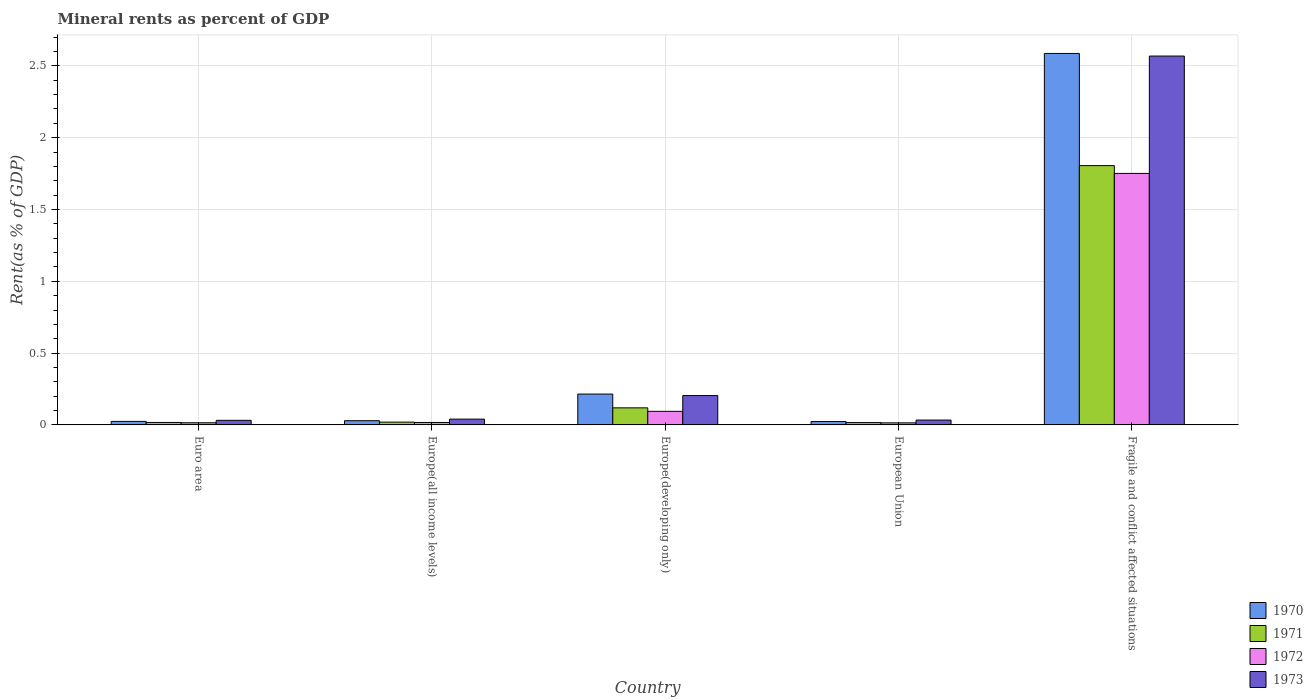How many bars are there on the 5th tick from the right?
Your response must be concise. 4. What is the label of the 4th group of bars from the left?
Provide a succinct answer. European Union. What is the mineral rent in 1971 in Europe(developing only)?
Offer a terse response. 0.12. Across all countries, what is the maximum mineral rent in 1971?
Give a very brief answer. 1.81. Across all countries, what is the minimum mineral rent in 1971?
Give a very brief answer. 0.02. In which country was the mineral rent in 1972 maximum?
Ensure brevity in your answer.  Fragile and conflict affected situations. What is the total mineral rent in 1972 in the graph?
Your answer should be very brief. 1.89. What is the difference between the mineral rent in 1971 in Europe(developing only) and that in European Union?
Your response must be concise. 0.1. What is the difference between the mineral rent in 1971 in Europe(developing only) and the mineral rent in 1973 in European Union?
Ensure brevity in your answer.  0.09. What is the average mineral rent in 1973 per country?
Keep it short and to the point. 0.58. What is the difference between the mineral rent of/in 1970 and mineral rent of/in 1972 in Euro area?
Your answer should be compact. 0.01. What is the ratio of the mineral rent in 1973 in Europe(all income levels) to that in Europe(developing only)?
Offer a very short reply. 0.2. Is the mineral rent in 1973 in Europe(developing only) less than that in European Union?
Keep it short and to the point. No. What is the difference between the highest and the second highest mineral rent in 1971?
Provide a succinct answer. -1.69. What is the difference between the highest and the lowest mineral rent in 1971?
Give a very brief answer. 1.79. Is the sum of the mineral rent in 1972 in Europe(developing only) and European Union greater than the maximum mineral rent in 1973 across all countries?
Ensure brevity in your answer.  No. How many bars are there?
Your response must be concise. 20. Are the values on the major ticks of Y-axis written in scientific E-notation?
Offer a terse response. No. How many legend labels are there?
Your answer should be very brief. 4. What is the title of the graph?
Your answer should be very brief. Mineral rents as percent of GDP. Does "2000" appear as one of the legend labels in the graph?
Your answer should be compact. No. What is the label or title of the X-axis?
Provide a short and direct response. Country. What is the label or title of the Y-axis?
Offer a terse response. Rent(as % of GDP). What is the Rent(as % of GDP) of 1970 in Euro area?
Offer a terse response. 0.02. What is the Rent(as % of GDP) of 1971 in Euro area?
Your response must be concise. 0.02. What is the Rent(as % of GDP) of 1972 in Euro area?
Make the answer very short. 0.02. What is the Rent(as % of GDP) of 1973 in Euro area?
Your answer should be compact. 0.03. What is the Rent(as % of GDP) in 1970 in Europe(all income levels)?
Give a very brief answer. 0.03. What is the Rent(as % of GDP) of 1971 in Europe(all income levels)?
Offer a very short reply. 0.02. What is the Rent(as % of GDP) of 1972 in Europe(all income levels)?
Provide a succinct answer. 0.02. What is the Rent(as % of GDP) of 1973 in Europe(all income levels)?
Keep it short and to the point. 0.04. What is the Rent(as % of GDP) of 1970 in Europe(developing only)?
Provide a short and direct response. 0.21. What is the Rent(as % of GDP) in 1971 in Europe(developing only)?
Your answer should be compact. 0.12. What is the Rent(as % of GDP) of 1972 in Europe(developing only)?
Offer a terse response. 0.09. What is the Rent(as % of GDP) in 1973 in Europe(developing only)?
Keep it short and to the point. 0.2. What is the Rent(as % of GDP) of 1970 in European Union?
Your response must be concise. 0.02. What is the Rent(as % of GDP) in 1971 in European Union?
Your response must be concise. 0.02. What is the Rent(as % of GDP) of 1972 in European Union?
Keep it short and to the point. 0.01. What is the Rent(as % of GDP) in 1973 in European Union?
Keep it short and to the point. 0.03. What is the Rent(as % of GDP) of 1970 in Fragile and conflict affected situations?
Provide a short and direct response. 2.59. What is the Rent(as % of GDP) in 1971 in Fragile and conflict affected situations?
Provide a succinct answer. 1.81. What is the Rent(as % of GDP) of 1972 in Fragile and conflict affected situations?
Offer a terse response. 1.75. What is the Rent(as % of GDP) in 1973 in Fragile and conflict affected situations?
Your response must be concise. 2.57. Across all countries, what is the maximum Rent(as % of GDP) of 1970?
Provide a succinct answer. 2.59. Across all countries, what is the maximum Rent(as % of GDP) in 1971?
Ensure brevity in your answer.  1.81. Across all countries, what is the maximum Rent(as % of GDP) in 1972?
Provide a succinct answer. 1.75. Across all countries, what is the maximum Rent(as % of GDP) in 1973?
Keep it short and to the point. 2.57. Across all countries, what is the minimum Rent(as % of GDP) in 1970?
Keep it short and to the point. 0.02. Across all countries, what is the minimum Rent(as % of GDP) in 1971?
Offer a very short reply. 0.02. Across all countries, what is the minimum Rent(as % of GDP) in 1972?
Provide a succinct answer. 0.01. Across all countries, what is the minimum Rent(as % of GDP) in 1973?
Offer a terse response. 0.03. What is the total Rent(as % of GDP) in 1970 in the graph?
Make the answer very short. 2.88. What is the total Rent(as % of GDP) in 1971 in the graph?
Offer a very short reply. 1.98. What is the total Rent(as % of GDP) of 1972 in the graph?
Your answer should be compact. 1.89. What is the total Rent(as % of GDP) of 1973 in the graph?
Keep it short and to the point. 2.88. What is the difference between the Rent(as % of GDP) of 1970 in Euro area and that in Europe(all income levels)?
Your response must be concise. -0. What is the difference between the Rent(as % of GDP) of 1971 in Euro area and that in Europe(all income levels)?
Your answer should be very brief. -0. What is the difference between the Rent(as % of GDP) of 1972 in Euro area and that in Europe(all income levels)?
Offer a terse response. -0. What is the difference between the Rent(as % of GDP) of 1973 in Euro area and that in Europe(all income levels)?
Keep it short and to the point. -0.01. What is the difference between the Rent(as % of GDP) in 1970 in Euro area and that in Europe(developing only)?
Provide a succinct answer. -0.19. What is the difference between the Rent(as % of GDP) of 1971 in Euro area and that in Europe(developing only)?
Offer a terse response. -0.1. What is the difference between the Rent(as % of GDP) in 1972 in Euro area and that in Europe(developing only)?
Offer a terse response. -0.08. What is the difference between the Rent(as % of GDP) of 1973 in Euro area and that in Europe(developing only)?
Keep it short and to the point. -0.17. What is the difference between the Rent(as % of GDP) of 1970 in Euro area and that in European Union?
Give a very brief answer. 0. What is the difference between the Rent(as % of GDP) of 1971 in Euro area and that in European Union?
Provide a short and direct response. 0. What is the difference between the Rent(as % of GDP) of 1972 in Euro area and that in European Union?
Offer a terse response. 0. What is the difference between the Rent(as % of GDP) of 1973 in Euro area and that in European Union?
Your answer should be very brief. -0. What is the difference between the Rent(as % of GDP) of 1970 in Euro area and that in Fragile and conflict affected situations?
Ensure brevity in your answer.  -2.56. What is the difference between the Rent(as % of GDP) of 1971 in Euro area and that in Fragile and conflict affected situations?
Make the answer very short. -1.79. What is the difference between the Rent(as % of GDP) of 1972 in Euro area and that in Fragile and conflict affected situations?
Offer a very short reply. -1.74. What is the difference between the Rent(as % of GDP) in 1973 in Euro area and that in Fragile and conflict affected situations?
Your response must be concise. -2.54. What is the difference between the Rent(as % of GDP) of 1970 in Europe(all income levels) and that in Europe(developing only)?
Keep it short and to the point. -0.19. What is the difference between the Rent(as % of GDP) in 1971 in Europe(all income levels) and that in Europe(developing only)?
Offer a terse response. -0.1. What is the difference between the Rent(as % of GDP) in 1972 in Europe(all income levels) and that in Europe(developing only)?
Give a very brief answer. -0.08. What is the difference between the Rent(as % of GDP) of 1973 in Europe(all income levels) and that in Europe(developing only)?
Offer a terse response. -0.16. What is the difference between the Rent(as % of GDP) of 1970 in Europe(all income levels) and that in European Union?
Ensure brevity in your answer.  0.01. What is the difference between the Rent(as % of GDP) in 1971 in Europe(all income levels) and that in European Union?
Your answer should be compact. 0. What is the difference between the Rent(as % of GDP) in 1972 in Europe(all income levels) and that in European Union?
Provide a succinct answer. 0. What is the difference between the Rent(as % of GDP) of 1973 in Europe(all income levels) and that in European Union?
Provide a succinct answer. 0.01. What is the difference between the Rent(as % of GDP) in 1970 in Europe(all income levels) and that in Fragile and conflict affected situations?
Keep it short and to the point. -2.56. What is the difference between the Rent(as % of GDP) in 1971 in Europe(all income levels) and that in Fragile and conflict affected situations?
Your answer should be compact. -1.79. What is the difference between the Rent(as % of GDP) in 1972 in Europe(all income levels) and that in Fragile and conflict affected situations?
Your response must be concise. -1.73. What is the difference between the Rent(as % of GDP) in 1973 in Europe(all income levels) and that in Fragile and conflict affected situations?
Offer a terse response. -2.53. What is the difference between the Rent(as % of GDP) in 1970 in Europe(developing only) and that in European Union?
Your response must be concise. 0.19. What is the difference between the Rent(as % of GDP) in 1971 in Europe(developing only) and that in European Union?
Your response must be concise. 0.1. What is the difference between the Rent(as % of GDP) in 1972 in Europe(developing only) and that in European Union?
Make the answer very short. 0.08. What is the difference between the Rent(as % of GDP) in 1973 in Europe(developing only) and that in European Union?
Provide a short and direct response. 0.17. What is the difference between the Rent(as % of GDP) of 1970 in Europe(developing only) and that in Fragile and conflict affected situations?
Your response must be concise. -2.37. What is the difference between the Rent(as % of GDP) of 1971 in Europe(developing only) and that in Fragile and conflict affected situations?
Offer a very short reply. -1.69. What is the difference between the Rent(as % of GDP) of 1972 in Europe(developing only) and that in Fragile and conflict affected situations?
Provide a short and direct response. -1.66. What is the difference between the Rent(as % of GDP) in 1973 in Europe(developing only) and that in Fragile and conflict affected situations?
Your answer should be very brief. -2.36. What is the difference between the Rent(as % of GDP) of 1970 in European Union and that in Fragile and conflict affected situations?
Your answer should be compact. -2.56. What is the difference between the Rent(as % of GDP) in 1971 in European Union and that in Fragile and conflict affected situations?
Ensure brevity in your answer.  -1.79. What is the difference between the Rent(as % of GDP) in 1972 in European Union and that in Fragile and conflict affected situations?
Offer a very short reply. -1.74. What is the difference between the Rent(as % of GDP) of 1973 in European Union and that in Fragile and conflict affected situations?
Give a very brief answer. -2.53. What is the difference between the Rent(as % of GDP) in 1970 in Euro area and the Rent(as % of GDP) in 1971 in Europe(all income levels)?
Offer a very short reply. 0.01. What is the difference between the Rent(as % of GDP) in 1970 in Euro area and the Rent(as % of GDP) in 1972 in Europe(all income levels)?
Make the answer very short. 0.01. What is the difference between the Rent(as % of GDP) in 1970 in Euro area and the Rent(as % of GDP) in 1973 in Europe(all income levels)?
Make the answer very short. -0.02. What is the difference between the Rent(as % of GDP) of 1971 in Euro area and the Rent(as % of GDP) of 1973 in Europe(all income levels)?
Keep it short and to the point. -0.02. What is the difference between the Rent(as % of GDP) in 1972 in Euro area and the Rent(as % of GDP) in 1973 in Europe(all income levels)?
Give a very brief answer. -0.03. What is the difference between the Rent(as % of GDP) in 1970 in Euro area and the Rent(as % of GDP) in 1971 in Europe(developing only)?
Ensure brevity in your answer.  -0.09. What is the difference between the Rent(as % of GDP) of 1970 in Euro area and the Rent(as % of GDP) of 1972 in Europe(developing only)?
Your answer should be compact. -0.07. What is the difference between the Rent(as % of GDP) of 1970 in Euro area and the Rent(as % of GDP) of 1973 in Europe(developing only)?
Offer a very short reply. -0.18. What is the difference between the Rent(as % of GDP) of 1971 in Euro area and the Rent(as % of GDP) of 1972 in Europe(developing only)?
Your answer should be very brief. -0.08. What is the difference between the Rent(as % of GDP) in 1971 in Euro area and the Rent(as % of GDP) in 1973 in Europe(developing only)?
Offer a terse response. -0.19. What is the difference between the Rent(as % of GDP) in 1972 in Euro area and the Rent(as % of GDP) in 1973 in Europe(developing only)?
Provide a succinct answer. -0.19. What is the difference between the Rent(as % of GDP) of 1970 in Euro area and the Rent(as % of GDP) of 1971 in European Union?
Your answer should be compact. 0.01. What is the difference between the Rent(as % of GDP) in 1970 in Euro area and the Rent(as % of GDP) in 1972 in European Union?
Your answer should be very brief. 0.01. What is the difference between the Rent(as % of GDP) in 1970 in Euro area and the Rent(as % of GDP) in 1973 in European Union?
Your answer should be compact. -0.01. What is the difference between the Rent(as % of GDP) in 1971 in Euro area and the Rent(as % of GDP) in 1972 in European Union?
Ensure brevity in your answer.  0. What is the difference between the Rent(as % of GDP) of 1971 in Euro area and the Rent(as % of GDP) of 1973 in European Union?
Your response must be concise. -0.02. What is the difference between the Rent(as % of GDP) in 1972 in Euro area and the Rent(as % of GDP) in 1973 in European Union?
Make the answer very short. -0.02. What is the difference between the Rent(as % of GDP) in 1970 in Euro area and the Rent(as % of GDP) in 1971 in Fragile and conflict affected situations?
Your response must be concise. -1.78. What is the difference between the Rent(as % of GDP) in 1970 in Euro area and the Rent(as % of GDP) in 1972 in Fragile and conflict affected situations?
Give a very brief answer. -1.73. What is the difference between the Rent(as % of GDP) of 1970 in Euro area and the Rent(as % of GDP) of 1973 in Fragile and conflict affected situations?
Offer a terse response. -2.54. What is the difference between the Rent(as % of GDP) of 1971 in Euro area and the Rent(as % of GDP) of 1972 in Fragile and conflict affected situations?
Offer a terse response. -1.73. What is the difference between the Rent(as % of GDP) of 1971 in Euro area and the Rent(as % of GDP) of 1973 in Fragile and conflict affected situations?
Your response must be concise. -2.55. What is the difference between the Rent(as % of GDP) of 1972 in Euro area and the Rent(as % of GDP) of 1973 in Fragile and conflict affected situations?
Keep it short and to the point. -2.55. What is the difference between the Rent(as % of GDP) of 1970 in Europe(all income levels) and the Rent(as % of GDP) of 1971 in Europe(developing only)?
Ensure brevity in your answer.  -0.09. What is the difference between the Rent(as % of GDP) in 1970 in Europe(all income levels) and the Rent(as % of GDP) in 1972 in Europe(developing only)?
Give a very brief answer. -0.07. What is the difference between the Rent(as % of GDP) in 1970 in Europe(all income levels) and the Rent(as % of GDP) in 1973 in Europe(developing only)?
Your answer should be very brief. -0.18. What is the difference between the Rent(as % of GDP) in 1971 in Europe(all income levels) and the Rent(as % of GDP) in 1972 in Europe(developing only)?
Your answer should be compact. -0.08. What is the difference between the Rent(as % of GDP) of 1971 in Europe(all income levels) and the Rent(as % of GDP) of 1973 in Europe(developing only)?
Your answer should be very brief. -0.18. What is the difference between the Rent(as % of GDP) in 1972 in Europe(all income levels) and the Rent(as % of GDP) in 1973 in Europe(developing only)?
Make the answer very short. -0.19. What is the difference between the Rent(as % of GDP) in 1970 in Europe(all income levels) and the Rent(as % of GDP) in 1971 in European Union?
Make the answer very short. 0.01. What is the difference between the Rent(as % of GDP) in 1970 in Europe(all income levels) and the Rent(as % of GDP) in 1972 in European Union?
Provide a succinct answer. 0.01. What is the difference between the Rent(as % of GDP) in 1970 in Europe(all income levels) and the Rent(as % of GDP) in 1973 in European Union?
Your answer should be compact. -0. What is the difference between the Rent(as % of GDP) of 1971 in Europe(all income levels) and the Rent(as % of GDP) of 1972 in European Union?
Offer a very short reply. 0.01. What is the difference between the Rent(as % of GDP) in 1971 in Europe(all income levels) and the Rent(as % of GDP) in 1973 in European Union?
Your answer should be compact. -0.01. What is the difference between the Rent(as % of GDP) in 1972 in Europe(all income levels) and the Rent(as % of GDP) in 1973 in European Union?
Make the answer very short. -0.02. What is the difference between the Rent(as % of GDP) of 1970 in Europe(all income levels) and the Rent(as % of GDP) of 1971 in Fragile and conflict affected situations?
Provide a succinct answer. -1.78. What is the difference between the Rent(as % of GDP) of 1970 in Europe(all income levels) and the Rent(as % of GDP) of 1972 in Fragile and conflict affected situations?
Offer a terse response. -1.72. What is the difference between the Rent(as % of GDP) of 1970 in Europe(all income levels) and the Rent(as % of GDP) of 1973 in Fragile and conflict affected situations?
Keep it short and to the point. -2.54. What is the difference between the Rent(as % of GDP) in 1971 in Europe(all income levels) and the Rent(as % of GDP) in 1972 in Fragile and conflict affected situations?
Provide a succinct answer. -1.73. What is the difference between the Rent(as % of GDP) of 1971 in Europe(all income levels) and the Rent(as % of GDP) of 1973 in Fragile and conflict affected situations?
Give a very brief answer. -2.55. What is the difference between the Rent(as % of GDP) in 1972 in Europe(all income levels) and the Rent(as % of GDP) in 1973 in Fragile and conflict affected situations?
Offer a very short reply. -2.55. What is the difference between the Rent(as % of GDP) of 1970 in Europe(developing only) and the Rent(as % of GDP) of 1971 in European Union?
Keep it short and to the point. 0.2. What is the difference between the Rent(as % of GDP) of 1970 in Europe(developing only) and the Rent(as % of GDP) of 1972 in European Union?
Your answer should be very brief. 0.2. What is the difference between the Rent(as % of GDP) in 1970 in Europe(developing only) and the Rent(as % of GDP) in 1973 in European Union?
Provide a short and direct response. 0.18. What is the difference between the Rent(as % of GDP) in 1971 in Europe(developing only) and the Rent(as % of GDP) in 1972 in European Union?
Offer a terse response. 0.1. What is the difference between the Rent(as % of GDP) in 1971 in Europe(developing only) and the Rent(as % of GDP) in 1973 in European Union?
Your answer should be compact. 0.09. What is the difference between the Rent(as % of GDP) of 1972 in Europe(developing only) and the Rent(as % of GDP) of 1973 in European Union?
Keep it short and to the point. 0.06. What is the difference between the Rent(as % of GDP) in 1970 in Europe(developing only) and the Rent(as % of GDP) in 1971 in Fragile and conflict affected situations?
Offer a terse response. -1.59. What is the difference between the Rent(as % of GDP) in 1970 in Europe(developing only) and the Rent(as % of GDP) in 1972 in Fragile and conflict affected situations?
Your response must be concise. -1.54. What is the difference between the Rent(as % of GDP) of 1970 in Europe(developing only) and the Rent(as % of GDP) of 1973 in Fragile and conflict affected situations?
Your answer should be very brief. -2.35. What is the difference between the Rent(as % of GDP) in 1971 in Europe(developing only) and the Rent(as % of GDP) in 1972 in Fragile and conflict affected situations?
Ensure brevity in your answer.  -1.63. What is the difference between the Rent(as % of GDP) of 1971 in Europe(developing only) and the Rent(as % of GDP) of 1973 in Fragile and conflict affected situations?
Provide a short and direct response. -2.45. What is the difference between the Rent(as % of GDP) of 1972 in Europe(developing only) and the Rent(as % of GDP) of 1973 in Fragile and conflict affected situations?
Make the answer very short. -2.47. What is the difference between the Rent(as % of GDP) in 1970 in European Union and the Rent(as % of GDP) in 1971 in Fragile and conflict affected situations?
Provide a succinct answer. -1.78. What is the difference between the Rent(as % of GDP) of 1970 in European Union and the Rent(as % of GDP) of 1972 in Fragile and conflict affected situations?
Ensure brevity in your answer.  -1.73. What is the difference between the Rent(as % of GDP) of 1970 in European Union and the Rent(as % of GDP) of 1973 in Fragile and conflict affected situations?
Your answer should be compact. -2.54. What is the difference between the Rent(as % of GDP) of 1971 in European Union and the Rent(as % of GDP) of 1972 in Fragile and conflict affected situations?
Provide a short and direct response. -1.73. What is the difference between the Rent(as % of GDP) of 1971 in European Union and the Rent(as % of GDP) of 1973 in Fragile and conflict affected situations?
Keep it short and to the point. -2.55. What is the difference between the Rent(as % of GDP) of 1972 in European Union and the Rent(as % of GDP) of 1973 in Fragile and conflict affected situations?
Make the answer very short. -2.55. What is the average Rent(as % of GDP) of 1970 per country?
Your response must be concise. 0.58. What is the average Rent(as % of GDP) in 1971 per country?
Offer a very short reply. 0.4. What is the average Rent(as % of GDP) of 1972 per country?
Provide a succinct answer. 0.38. What is the average Rent(as % of GDP) of 1973 per country?
Give a very brief answer. 0.58. What is the difference between the Rent(as % of GDP) in 1970 and Rent(as % of GDP) in 1971 in Euro area?
Make the answer very short. 0.01. What is the difference between the Rent(as % of GDP) of 1970 and Rent(as % of GDP) of 1972 in Euro area?
Provide a short and direct response. 0.01. What is the difference between the Rent(as % of GDP) of 1970 and Rent(as % of GDP) of 1973 in Euro area?
Your response must be concise. -0.01. What is the difference between the Rent(as % of GDP) in 1971 and Rent(as % of GDP) in 1972 in Euro area?
Offer a very short reply. 0. What is the difference between the Rent(as % of GDP) in 1971 and Rent(as % of GDP) in 1973 in Euro area?
Make the answer very short. -0.01. What is the difference between the Rent(as % of GDP) in 1972 and Rent(as % of GDP) in 1973 in Euro area?
Your answer should be very brief. -0.02. What is the difference between the Rent(as % of GDP) in 1970 and Rent(as % of GDP) in 1971 in Europe(all income levels)?
Your response must be concise. 0.01. What is the difference between the Rent(as % of GDP) of 1970 and Rent(as % of GDP) of 1972 in Europe(all income levels)?
Your answer should be compact. 0.01. What is the difference between the Rent(as % of GDP) of 1970 and Rent(as % of GDP) of 1973 in Europe(all income levels)?
Provide a succinct answer. -0.01. What is the difference between the Rent(as % of GDP) of 1971 and Rent(as % of GDP) of 1972 in Europe(all income levels)?
Give a very brief answer. 0. What is the difference between the Rent(as % of GDP) of 1971 and Rent(as % of GDP) of 1973 in Europe(all income levels)?
Your answer should be compact. -0.02. What is the difference between the Rent(as % of GDP) in 1972 and Rent(as % of GDP) in 1973 in Europe(all income levels)?
Give a very brief answer. -0.02. What is the difference between the Rent(as % of GDP) of 1970 and Rent(as % of GDP) of 1971 in Europe(developing only)?
Offer a very short reply. 0.1. What is the difference between the Rent(as % of GDP) in 1970 and Rent(as % of GDP) in 1972 in Europe(developing only)?
Give a very brief answer. 0.12. What is the difference between the Rent(as % of GDP) in 1970 and Rent(as % of GDP) in 1973 in Europe(developing only)?
Give a very brief answer. 0.01. What is the difference between the Rent(as % of GDP) of 1971 and Rent(as % of GDP) of 1972 in Europe(developing only)?
Your answer should be compact. 0.02. What is the difference between the Rent(as % of GDP) of 1971 and Rent(as % of GDP) of 1973 in Europe(developing only)?
Ensure brevity in your answer.  -0.09. What is the difference between the Rent(as % of GDP) in 1972 and Rent(as % of GDP) in 1973 in Europe(developing only)?
Your response must be concise. -0.11. What is the difference between the Rent(as % of GDP) of 1970 and Rent(as % of GDP) of 1971 in European Union?
Your response must be concise. 0.01. What is the difference between the Rent(as % of GDP) of 1970 and Rent(as % of GDP) of 1972 in European Union?
Give a very brief answer. 0.01. What is the difference between the Rent(as % of GDP) in 1970 and Rent(as % of GDP) in 1973 in European Union?
Provide a short and direct response. -0.01. What is the difference between the Rent(as % of GDP) in 1971 and Rent(as % of GDP) in 1972 in European Union?
Provide a short and direct response. 0. What is the difference between the Rent(as % of GDP) of 1971 and Rent(as % of GDP) of 1973 in European Union?
Give a very brief answer. -0.02. What is the difference between the Rent(as % of GDP) of 1972 and Rent(as % of GDP) of 1973 in European Union?
Give a very brief answer. -0.02. What is the difference between the Rent(as % of GDP) in 1970 and Rent(as % of GDP) in 1971 in Fragile and conflict affected situations?
Provide a short and direct response. 0.78. What is the difference between the Rent(as % of GDP) in 1970 and Rent(as % of GDP) in 1972 in Fragile and conflict affected situations?
Ensure brevity in your answer.  0.84. What is the difference between the Rent(as % of GDP) of 1970 and Rent(as % of GDP) of 1973 in Fragile and conflict affected situations?
Make the answer very short. 0.02. What is the difference between the Rent(as % of GDP) of 1971 and Rent(as % of GDP) of 1972 in Fragile and conflict affected situations?
Ensure brevity in your answer.  0.05. What is the difference between the Rent(as % of GDP) in 1971 and Rent(as % of GDP) in 1973 in Fragile and conflict affected situations?
Make the answer very short. -0.76. What is the difference between the Rent(as % of GDP) of 1972 and Rent(as % of GDP) of 1973 in Fragile and conflict affected situations?
Make the answer very short. -0.82. What is the ratio of the Rent(as % of GDP) of 1970 in Euro area to that in Europe(all income levels)?
Keep it short and to the point. 0.84. What is the ratio of the Rent(as % of GDP) in 1971 in Euro area to that in Europe(all income levels)?
Your answer should be very brief. 0.88. What is the ratio of the Rent(as % of GDP) of 1972 in Euro area to that in Europe(all income levels)?
Your answer should be compact. 0.89. What is the ratio of the Rent(as % of GDP) in 1973 in Euro area to that in Europe(all income levels)?
Your answer should be compact. 0.79. What is the ratio of the Rent(as % of GDP) of 1970 in Euro area to that in Europe(developing only)?
Provide a short and direct response. 0.11. What is the ratio of the Rent(as % of GDP) in 1971 in Euro area to that in Europe(developing only)?
Your answer should be compact. 0.14. What is the ratio of the Rent(as % of GDP) of 1972 in Euro area to that in Europe(developing only)?
Offer a terse response. 0.16. What is the ratio of the Rent(as % of GDP) of 1973 in Euro area to that in Europe(developing only)?
Ensure brevity in your answer.  0.16. What is the ratio of the Rent(as % of GDP) of 1970 in Euro area to that in European Union?
Provide a short and direct response. 1.05. What is the ratio of the Rent(as % of GDP) of 1971 in Euro area to that in European Union?
Your response must be concise. 1.05. What is the ratio of the Rent(as % of GDP) of 1972 in Euro area to that in European Union?
Offer a terse response. 1.05. What is the ratio of the Rent(as % of GDP) of 1973 in Euro area to that in European Union?
Keep it short and to the point. 0.95. What is the ratio of the Rent(as % of GDP) of 1970 in Euro area to that in Fragile and conflict affected situations?
Provide a succinct answer. 0.01. What is the ratio of the Rent(as % of GDP) in 1971 in Euro area to that in Fragile and conflict affected situations?
Offer a very short reply. 0.01. What is the ratio of the Rent(as % of GDP) in 1972 in Euro area to that in Fragile and conflict affected situations?
Make the answer very short. 0.01. What is the ratio of the Rent(as % of GDP) in 1973 in Euro area to that in Fragile and conflict affected situations?
Provide a short and direct response. 0.01. What is the ratio of the Rent(as % of GDP) of 1970 in Europe(all income levels) to that in Europe(developing only)?
Offer a very short reply. 0.14. What is the ratio of the Rent(as % of GDP) of 1971 in Europe(all income levels) to that in Europe(developing only)?
Your response must be concise. 0.16. What is the ratio of the Rent(as % of GDP) in 1972 in Europe(all income levels) to that in Europe(developing only)?
Provide a short and direct response. 0.18. What is the ratio of the Rent(as % of GDP) in 1973 in Europe(all income levels) to that in Europe(developing only)?
Offer a terse response. 0.2. What is the ratio of the Rent(as % of GDP) of 1970 in Europe(all income levels) to that in European Union?
Keep it short and to the point. 1.25. What is the ratio of the Rent(as % of GDP) in 1971 in Europe(all income levels) to that in European Union?
Your answer should be compact. 1.19. What is the ratio of the Rent(as % of GDP) of 1972 in Europe(all income levels) to that in European Union?
Ensure brevity in your answer.  1.18. What is the ratio of the Rent(as % of GDP) in 1973 in Europe(all income levels) to that in European Union?
Offer a terse response. 1.19. What is the ratio of the Rent(as % of GDP) in 1970 in Europe(all income levels) to that in Fragile and conflict affected situations?
Offer a terse response. 0.01. What is the ratio of the Rent(as % of GDP) in 1971 in Europe(all income levels) to that in Fragile and conflict affected situations?
Your answer should be compact. 0.01. What is the ratio of the Rent(as % of GDP) in 1972 in Europe(all income levels) to that in Fragile and conflict affected situations?
Provide a short and direct response. 0.01. What is the ratio of the Rent(as % of GDP) in 1973 in Europe(all income levels) to that in Fragile and conflict affected situations?
Ensure brevity in your answer.  0.02. What is the ratio of the Rent(as % of GDP) in 1970 in Europe(developing only) to that in European Union?
Make the answer very short. 9.2. What is the ratio of the Rent(as % of GDP) of 1971 in Europe(developing only) to that in European Union?
Provide a short and direct response. 7.31. What is the ratio of the Rent(as % of GDP) of 1972 in Europe(developing only) to that in European Union?
Your answer should be very brief. 6.59. What is the ratio of the Rent(as % of GDP) in 1973 in Europe(developing only) to that in European Union?
Offer a terse response. 6.06. What is the ratio of the Rent(as % of GDP) of 1970 in Europe(developing only) to that in Fragile and conflict affected situations?
Offer a very short reply. 0.08. What is the ratio of the Rent(as % of GDP) in 1971 in Europe(developing only) to that in Fragile and conflict affected situations?
Offer a very short reply. 0.07. What is the ratio of the Rent(as % of GDP) of 1972 in Europe(developing only) to that in Fragile and conflict affected situations?
Make the answer very short. 0.05. What is the ratio of the Rent(as % of GDP) of 1973 in Europe(developing only) to that in Fragile and conflict affected situations?
Give a very brief answer. 0.08. What is the ratio of the Rent(as % of GDP) of 1970 in European Union to that in Fragile and conflict affected situations?
Provide a succinct answer. 0.01. What is the ratio of the Rent(as % of GDP) of 1971 in European Union to that in Fragile and conflict affected situations?
Provide a short and direct response. 0.01. What is the ratio of the Rent(as % of GDP) of 1972 in European Union to that in Fragile and conflict affected situations?
Your answer should be very brief. 0.01. What is the ratio of the Rent(as % of GDP) in 1973 in European Union to that in Fragile and conflict affected situations?
Offer a terse response. 0.01. What is the difference between the highest and the second highest Rent(as % of GDP) of 1970?
Provide a short and direct response. 2.37. What is the difference between the highest and the second highest Rent(as % of GDP) in 1971?
Offer a very short reply. 1.69. What is the difference between the highest and the second highest Rent(as % of GDP) in 1972?
Offer a very short reply. 1.66. What is the difference between the highest and the second highest Rent(as % of GDP) of 1973?
Offer a very short reply. 2.36. What is the difference between the highest and the lowest Rent(as % of GDP) in 1970?
Your answer should be very brief. 2.56. What is the difference between the highest and the lowest Rent(as % of GDP) of 1971?
Your answer should be very brief. 1.79. What is the difference between the highest and the lowest Rent(as % of GDP) of 1972?
Your response must be concise. 1.74. What is the difference between the highest and the lowest Rent(as % of GDP) in 1973?
Offer a terse response. 2.54. 